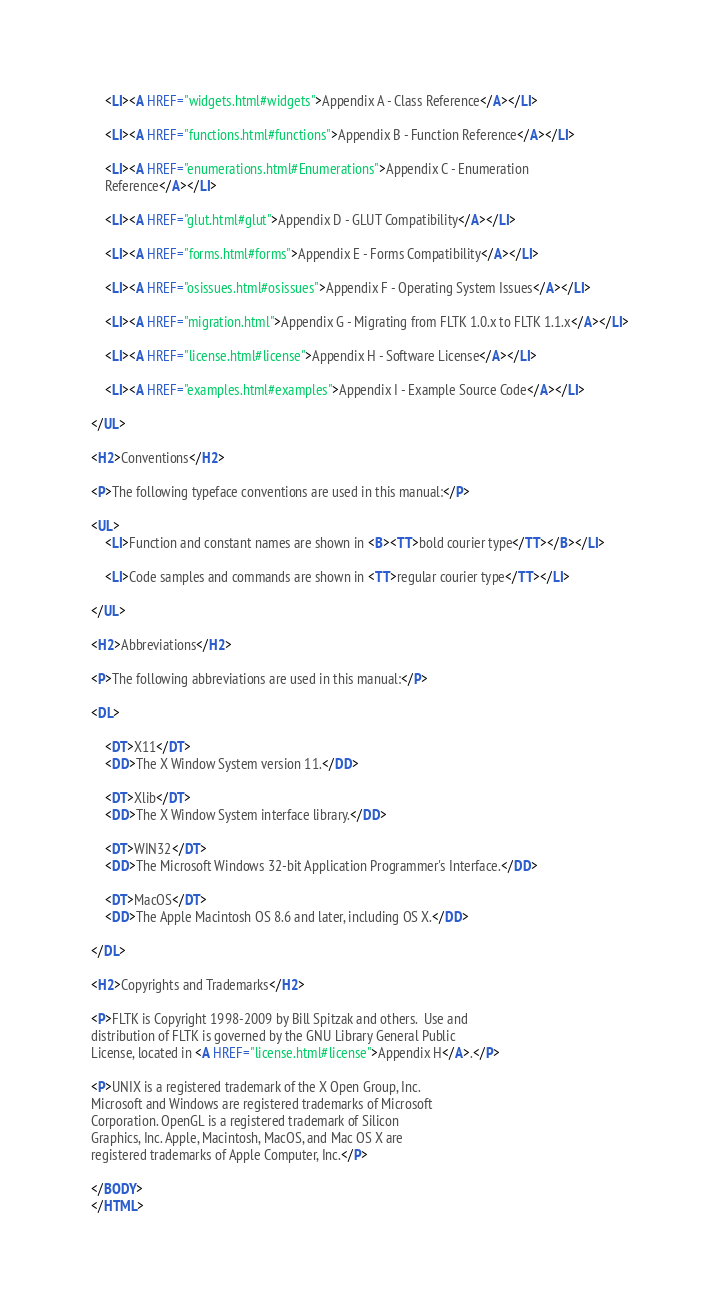<code> <loc_0><loc_0><loc_500><loc_500><_HTML_>	<LI><A HREF="widgets.html#widgets">Appendix A - Class Reference</A></LI>

	<LI><A HREF="functions.html#functions">Appendix B - Function Reference</A></LI>

	<LI><A HREF="enumerations.html#Enumerations">Appendix C - Enumeration
	Reference</A></LI>

	<LI><A HREF="glut.html#glut">Appendix D - GLUT Compatibility</A></LI>

	<LI><A HREF="forms.html#forms">Appendix E - Forms Compatibility</A></LI>

	<LI><A HREF="osissues.html#osissues">Appendix F - Operating System Issues</A></LI>

	<LI><A HREF="migration.html">Appendix G - Migrating from FLTK 1.0.x to FLTK 1.1.x</A></LI>

	<LI><A HREF="license.html#license">Appendix H - Software License</A></LI>

	<LI><A HREF="examples.html#examples">Appendix I - Example Source Code</A></LI>

</UL>

<H2>Conventions</H2>

<P>The following typeface conventions are used in this manual:</P>

<UL>
	<LI>Function and constant names are shown in <B><TT>bold courier type</TT></B></LI>

	<LI>Code samples and commands are shown in <TT>regular courier type</TT></LI>

</UL>

<H2>Abbreviations</H2>

<P>The following abbreviations are used in this manual:</P>

<DL>

	<DT>X11</DT>
	<DD>The X Window System version 11.</DD>

	<DT>Xlib</DT>
	<DD>The X Window System interface library.</DD>

	<DT>WIN32</DT>
	<DD>The Microsoft Windows 32-bit Application Programmer's Interface.</DD>

	<DT>MacOS</DT>
	<DD>The Apple Macintosh OS 8.6 and later, including OS X.</DD>

</DL>

<H2>Copyrights and Trademarks</H2>

<P>FLTK is Copyright 1998-2009 by Bill Spitzak and others.  Use and
distribution of FLTK is governed by the GNU Library General Public
License, located in <A HREF="license.html#license">Appendix H</A>.</P>

<P>UNIX is a registered trademark of the X Open Group, Inc. 
Microsoft and Windows are registered trademarks of Microsoft
Corporation. OpenGL is a registered trademark of Silicon
Graphics, Inc. Apple, Macintosh, MacOS, and Mac OS X are
registered trademarks of Apple Computer, Inc.</P>

</BODY>
</HTML>
</code> 